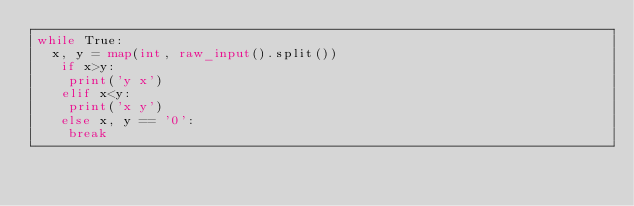<code> <loc_0><loc_0><loc_500><loc_500><_Python_>while True:
  x, y = map(int, raw_input().split())
   if x>y:
    print('y x') 
   elif x<y:  
    print('x y')
   else x, y == '0':
    break</code> 